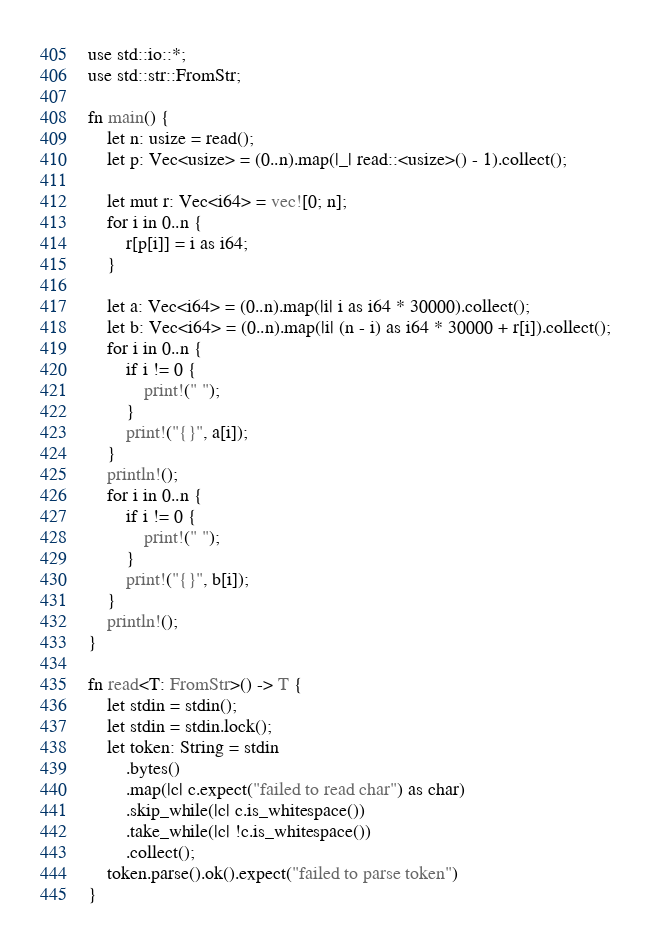Convert code to text. <code><loc_0><loc_0><loc_500><loc_500><_Rust_>use std::io::*;
use std::str::FromStr;

fn main() {
    let n: usize = read();
    let p: Vec<usize> = (0..n).map(|_| read::<usize>() - 1).collect();

    let mut r: Vec<i64> = vec![0; n];
    for i in 0..n {
        r[p[i]] = i as i64;
    }

    let a: Vec<i64> = (0..n).map(|i| i as i64 * 30000).collect();
    let b: Vec<i64> = (0..n).map(|i| (n - i) as i64 * 30000 + r[i]).collect();
    for i in 0..n {
        if i != 0 {
            print!(" ");
        }
        print!("{}", a[i]);
    }
    println!();
    for i in 0..n {
        if i != 0 {
            print!(" ");
        }
        print!("{}", b[i]);
    }
    println!();
}

fn read<T: FromStr>() -> T {
    let stdin = stdin();
    let stdin = stdin.lock();
    let token: String = stdin
        .bytes()
        .map(|c| c.expect("failed to read char") as char)
        .skip_while(|c| c.is_whitespace())
        .take_while(|c| !c.is_whitespace())
        .collect();
    token.parse().ok().expect("failed to parse token")
}
</code> 